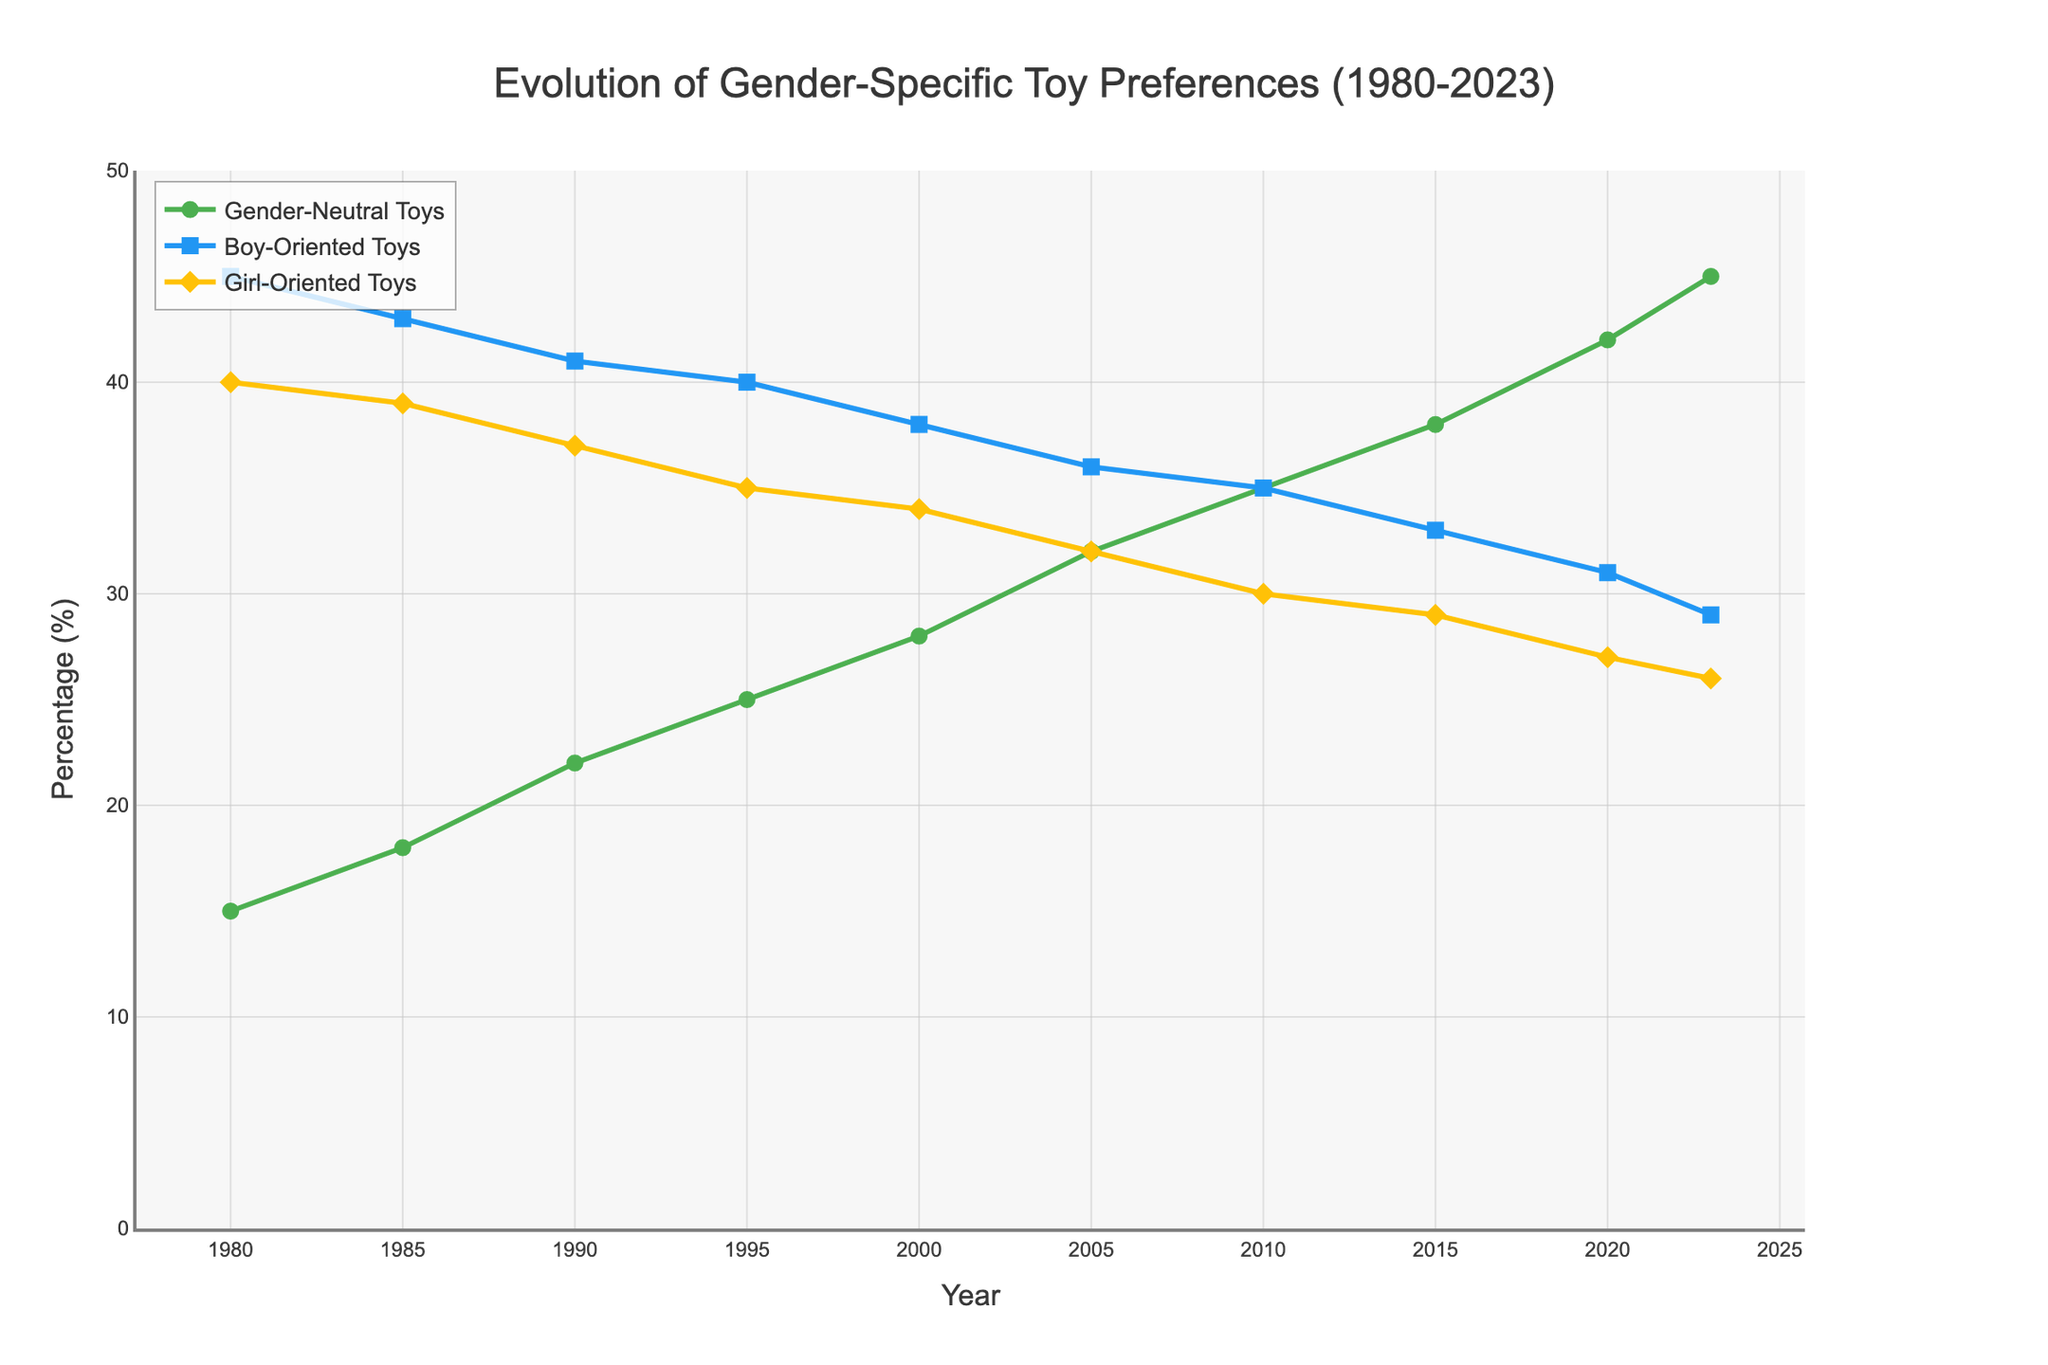What percentage of children preferred Gender-Neutral Toys in 1990? Check the line for Gender-Neutral Toys and find the value at the year 1990.
Answer: 22% How much did the preference for Girl-Oriented Toys decrease between 1980 and 2023? Subtract the percentage of Girl-Oriented Toys in 2023 from the percentage in 1980 (40% - 26% = 14%).
Answer: 14% In which year did Boy-Oriented Toys and Girl-Oriented Toys both equal 35%? Find the year where the values of Boy-Oriented Toys and Girl-Oriented Toys intersect at 35%.
Answer: 2010 What is the average percentage of Gender-Neutral Toys from 1980 to 2023? Sum the percentages of Gender-Neutral Toys for all years and divide by the number of years: (15 + 18 + 22 + 25 + 28 + 32 + 35 + 38 + 42 + 45) / 10
Answer: 30% Which type of toys had the highest increase in preference from 1980 to 2023? Calculate the increase for each type of toy by subtracting the 1980 value from the 2023 value and compare increases: Gender-Neutral (45% - 15% = 30%), Boy-Oriented (29% - 45% = -16%), Girl-Oriented (26% - 40% = -14%).
Answer: Gender-Neutral In which year was the difference between Boy-Oriented and Girl-Oriented Toys the smallest? Calculate the absolute differences for each year and find the year with the smallest difference.
Answer: 2015 What is the combined percentage of Boy-Oriented and Girl-Oriented Toys in 2020? Add the percentages of Boy-Oriented and Girl-Oriented Toys in 2020 (31% + 27% = 58%).
Answer: 58% Between which consecutive years did the preference for Gender-Neutral Toys increase the most? Calculate the differences between consecutive years for Gender-Neutral Toys and identify the maximum increase: 1980-1985 (3%), 1985-1990 (4%), 1990-1995 (3%), 1995-2000 (3%), 2000-2005 (4%), 2005-2010 (3%), 2010-2015 (3%), 2015-2020 (4%), 2020-2023 (3%).
Answer: 1985 to 1990, 2000 to 2005, 2015 to 2020 What percentage of children preferred Boy-Oriented Toys in the last recorded year? Check the line for Boy-Oriented Toys and find the value at the year 2023.
Answer: 29% By how much did the preference for Girl-Oriented Toys differ from Boy-Oriented Toys in 2000? Subtract the percentage of Boy-Oriented Toys from the percentage of Girl-Oriented Toys in 2000 (38% - 34% = 4%).
Answer: 4% 